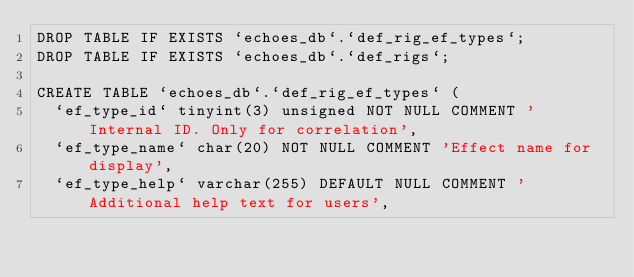Convert code to text. <code><loc_0><loc_0><loc_500><loc_500><_SQL_>DROP TABLE IF EXISTS `echoes_db`.`def_rig_ef_types`;
DROP TABLE IF EXISTS `echoes_db`.`def_rigs`;

CREATE TABLE `echoes_db`.`def_rig_ef_types` (
	`ef_type_id` tinyint(3) unsigned NOT NULL COMMENT 'Internal ID. Only for correlation',
	`ef_type_name` char(20) NOT NULL COMMENT 'Effect name for display',
	`ef_type_help` varchar(255) DEFAULT NULL COMMENT 'Additional help text for users',</code> 